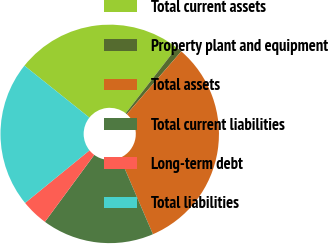<chart> <loc_0><loc_0><loc_500><loc_500><pie_chart><fcel>Total current assets<fcel>Property plant and equipment<fcel>Total assets<fcel>Total current liabilities<fcel>Long-term debt<fcel>Total liabilities<nl><fcel>24.76%<fcel>0.87%<fcel>32.16%<fcel>16.58%<fcel>4.0%<fcel>21.63%<nl></chart> 